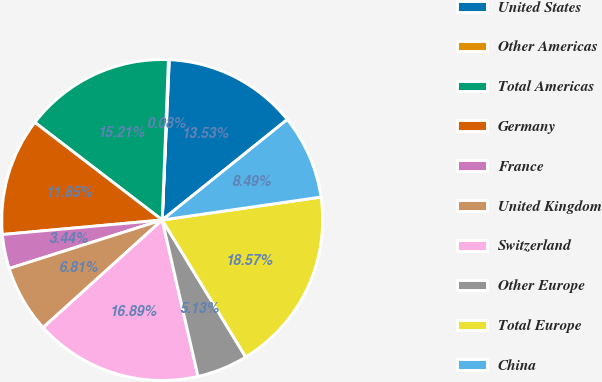Convert chart. <chart><loc_0><loc_0><loc_500><loc_500><pie_chart><fcel>United States<fcel>Other Americas<fcel>Total Americas<fcel>Germany<fcel>France<fcel>United Kingdom<fcel>Switzerland<fcel>Other Europe<fcel>Total Europe<fcel>China<nl><fcel>13.53%<fcel>0.08%<fcel>15.21%<fcel>11.85%<fcel>3.44%<fcel>6.81%<fcel>16.89%<fcel>5.13%<fcel>18.57%<fcel>8.49%<nl></chart> 